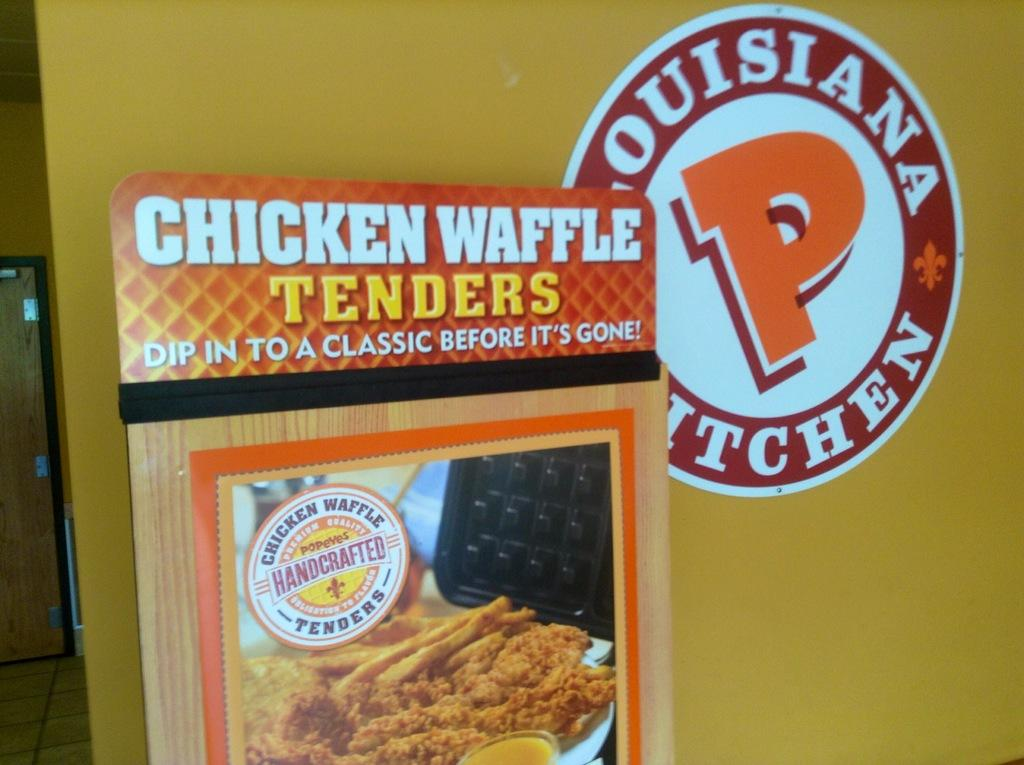What is featured on the poster in the image? The poster in the image has images and text. What can be seen on the wall in the image? There is a picture on the wall in the image. What is a possible way to enter or exit the space in the image? The door visible in the image can be used for entering or exiting. What is visible beneath the poster and wall in the image? The ground is visible in the image. What type of story is being told by the people at the party in the image? There is no party or people present in the image; it only features a poster, a wall with a picture, a door, and the ground. How many people are swimming in the image? There are no people or swimming activity depicted in the image. 